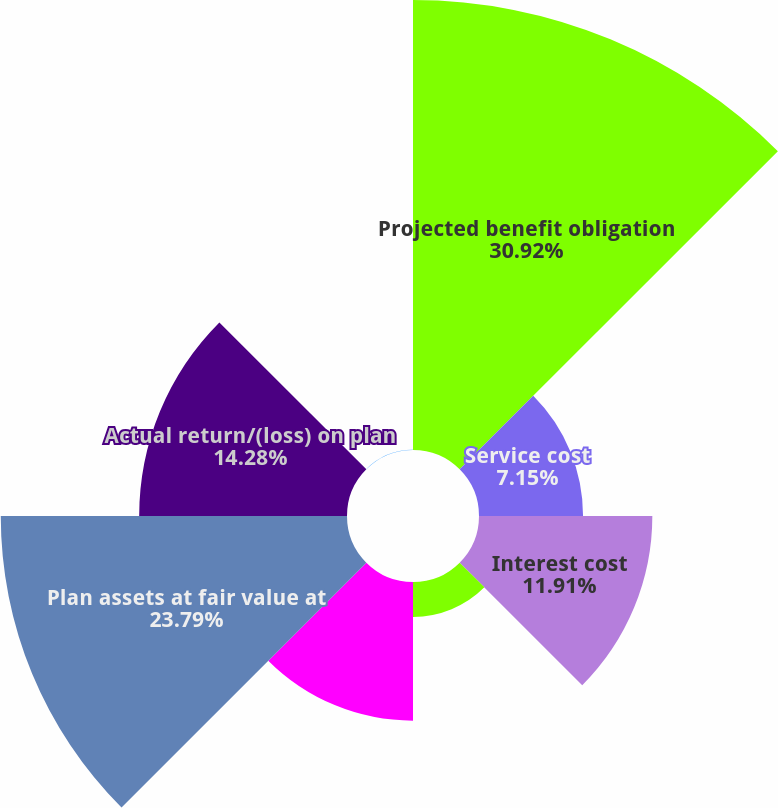Convert chart to OTSL. <chart><loc_0><loc_0><loc_500><loc_500><pie_chart><fcel>Projected benefit obligation<fcel>Service cost<fcel>Interest cost<fcel>Actuarial losses/(gains)<fcel>Benefits paid<fcel>Plan assets at fair value at<fcel>Actual return/(loss) on plan<fcel>Company contributions<nl><fcel>30.92%<fcel>7.15%<fcel>11.91%<fcel>2.4%<fcel>9.53%<fcel>23.79%<fcel>14.28%<fcel>0.02%<nl></chart> 